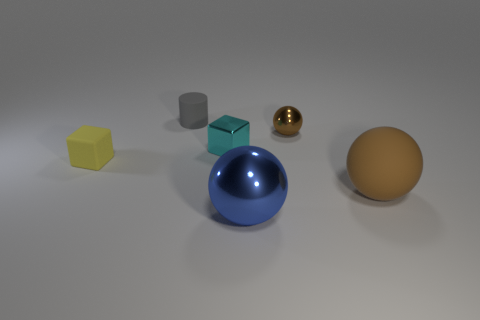Add 3 cyan matte things. How many objects exist? 9 Subtract all cylinders. How many objects are left? 5 Subtract 0 gray blocks. How many objects are left? 6 Subtract all tiny cyan cubes. Subtract all metallic blocks. How many objects are left? 4 Add 1 big rubber balls. How many big rubber balls are left? 2 Add 1 rubber spheres. How many rubber spheres exist? 2 